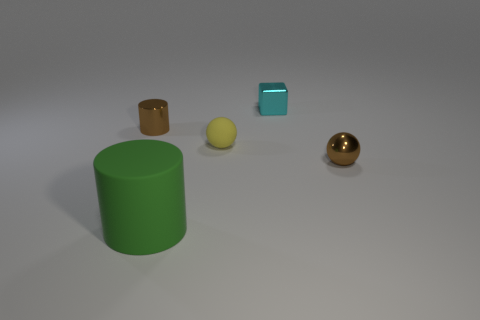Are there any other things that are the same color as the small matte thing?
Offer a very short reply. No. What size is the brown sphere that is made of the same material as the block?
Your answer should be compact. Small. What is the material of the cylinder in front of the metal object that is left of the cylinder to the right of the tiny metal cylinder?
Provide a short and direct response. Rubber. Is the number of purple blocks less than the number of tiny cyan blocks?
Ensure brevity in your answer.  Yes. Are the small cyan cube and the brown cylinder made of the same material?
Your answer should be compact. Yes. There is a shiny thing that is the same color as the small metal sphere; what shape is it?
Keep it short and to the point. Cylinder. Is the color of the thing left of the big green thing the same as the metallic ball?
Ensure brevity in your answer.  Yes. How many tiny brown shiny things are behind the matte thing behind the big object?
Provide a succinct answer. 1. There is a cylinder that is the same size as the brown shiny ball; what is its color?
Your answer should be compact. Brown. There is a cylinder that is behind the metallic ball; what is its material?
Give a very brief answer. Metal. 